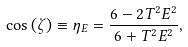<formula> <loc_0><loc_0><loc_500><loc_500>\cos \left ( \zeta \right ) \equiv \eta _ { E } = \frac { 6 - 2 T ^ { 2 } E ^ { 2 } } { 6 + T ^ { 2 } E ^ { 2 } } ,</formula> 